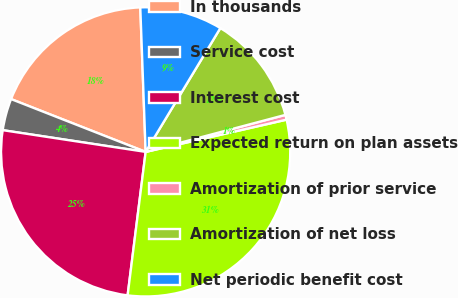Convert chart. <chart><loc_0><loc_0><loc_500><loc_500><pie_chart><fcel>In thousands<fcel>Service cost<fcel>Interest cost<fcel>Expected return on plan assets<fcel>Amortization of prior service<fcel>Amortization of net loss<fcel>Net periodic benefit cost<nl><fcel>18.46%<fcel>3.55%<fcel>25.41%<fcel>30.57%<fcel>0.54%<fcel>12.24%<fcel>9.23%<nl></chart> 